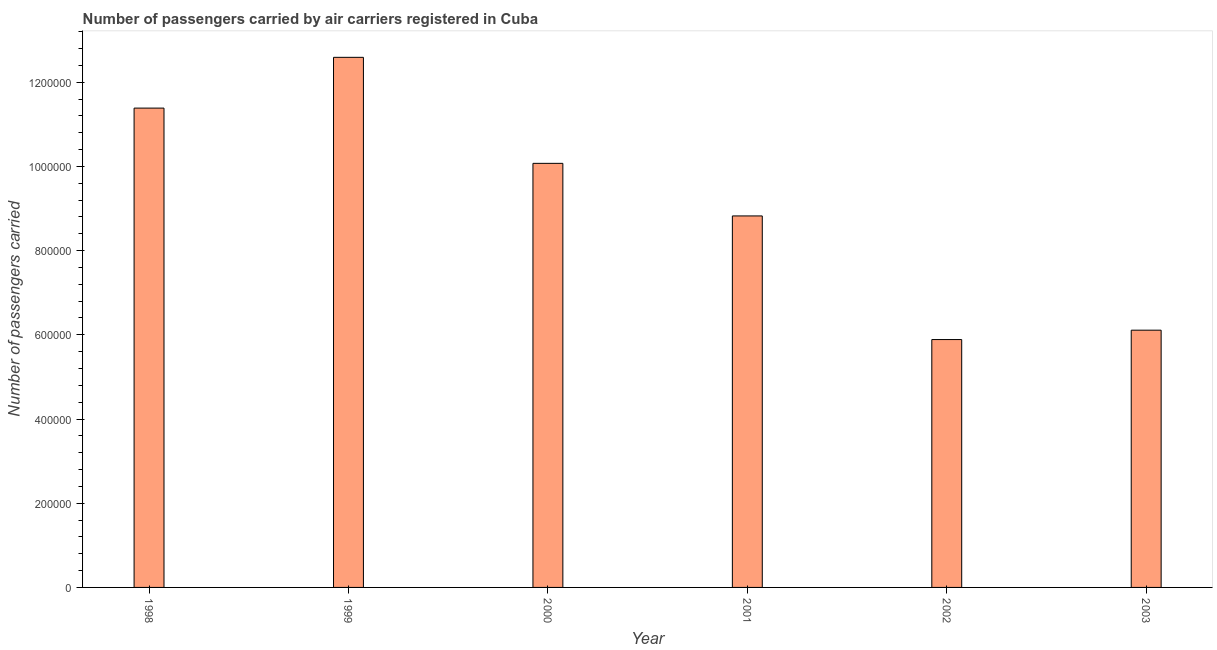Does the graph contain any zero values?
Offer a very short reply. No. Does the graph contain grids?
Offer a terse response. No. What is the title of the graph?
Your answer should be compact. Number of passengers carried by air carriers registered in Cuba. What is the label or title of the X-axis?
Provide a succinct answer. Year. What is the label or title of the Y-axis?
Offer a terse response. Number of passengers carried. What is the number of passengers carried in 2000?
Your response must be concise. 1.01e+06. Across all years, what is the maximum number of passengers carried?
Offer a terse response. 1.26e+06. Across all years, what is the minimum number of passengers carried?
Your answer should be compact. 5.89e+05. In which year was the number of passengers carried maximum?
Provide a short and direct response. 1999. What is the sum of the number of passengers carried?
Ensure brevity in your answer.  5.49e+06. What is the difference between the number of passengers carried in 2001 and 2003?
Ensure brevity in your answer.  2.71e+05. What is the average number of passengers carried per year?
Make the answer very short. 9.14e+05. What is the median number of passengers carried?
Give a very brief answer. 9.45e+05. In how many years, is the number of passengers carried greater than 1040000 ?
Provide a short and direct response. 2. Do a majority of the years between 2003 and 2000 (inclusive) have number of passengers carried greater than 120000 ?
Offer a very short reply. Yes. What is the ratio of the number of passengers carried in 1998 to that in 2003?
Your answer should be compact. 1.86. What is the difference between the highest and the second highest number of passengers carried?
Offer a very short reply. 1.21e+05. What is the difference between the highest and the lowest number of passengers carried?
Ensure brevity in your answer.  6.70e+05. How many bars are there?
Keep it short and to the point. 6. How many years are there in the graph?
Your answer should be compact. 6. What is the difference between two consecutive major ticks on the Y-axis?
Your answer should be very brief. 2.00e+05. Are the values on the major ticks of Y-axis written in scientific E-notation?
Give a very brief answer. No. What is the Number of passengers carried of 1998?
Offer a very short reply. 1.14e+06. What is the Number of passengers carried of 1999?
Offer a very short reply. 1.26e+06. What is the Number of passengers carried in 2000?
Your answer should be very brief. 1.01e+06. What is the Number of passengers carried of 2001?
Your answer should be compact. 8.82e+05. What is the Number of passengers carried in 2002?
Give a very brief answer. 5.89e+05. What is the Number of passengers carried in 2003?
Make the answer very short. 6.11e+05. What is the difference between the Number of passengers carried in 1998 and 1999?
Provide a succinct answer. -1.21e+05. What is the difference between the Number of passengers carried in 1998 and 2000?
Ensure brevity in your answer.  1.31e+05. What is the difference between the Number of passengers carried in 1998 and 2001?
Offer a very short reply. 2.56e+05. What is the difference between the Number of passengers carried in 1998 and 2002?
Offer a terse response. 5.50e+05. What is the difference between the Number of passengers carried in 1998 and 2003?
Ensure brevity in your answer.  5.27e+05. What is the difference between the Number of passengers carried in 1999 and 2000?
Offer a terse response. 2.52e+05. What is the difference between the Number of passengers carried in 1999 and 2001?
Provide a short and direct response. 3.77e+05. What is the difference between the Number of passengers carried in 1999 and 2002?
Offer a terse response. 6.70e+05. What is the difference between the Number of passengers carried in 1999 and 2003?
Offer a very short reply. 6.48e+05. What is the difference between the Number of passengers carried in 2000 and 2001?
Give a very brief answer. 1.25e+05. What is the difference between the Number of passengers carried in 2000 and 2002?
Give a very brief answer. 4.18e+05. What is the difference between the Number of passengers carried in 2000 and 2003?
Your answer should be very brief. 3.96e+05. What is the difference between the Number of passengers carried in 2001 and 2002?
Offer a terse response. 2.94e+05. What is the difference between the Number of passengers carried in 2001 and 2003?
Provide a short and direct response. 2.71e+05. What is the difference between the Number of passengers carried in 2002 and 2003?
Ensure brevity in your answer.  -2.23e+04. What is the ratio of the Number of passengers carried in 1998 to that in 1999?
Provide a short and direct response. 0.9. What is the ratio of the Number of passengers carried in 1998 to that in 2000?
Your answer should be compact. 1.13. What is the ratio of the Number of passengers carried in 1998 to that in 2001?
Provide a succinct answer. 1.29. What is the ratio of the Number of passengers carried in 1998 to that in 2002?
Offer a very short reply. 1.93. What is the ratio of the Number of passengers carried in 1998 to that in 2003?
Give a very brief answer. 1.86. What is the ratio of the Number of passengers carried in 1999 to that in 2000?
Ensure brevity in your answer.  1.25. What is the ratio of the Number of passengers carried in 1999 to that in 2001?
Provide a succinct answer. 1.43. What is the ratio of the Number of passengers carried in 1999 to that in 2002?
Provide a succinct answer. 2.14. What is the ratio of the Number of passengers carried in 1999 to that in 2003?
Offer a very short reply. 2.06. What is the ratio of the Number of passengers carried in 2000 to that in 2001?
Your response must be concise. 1.14. What is the ratio of the Number of passengers carried in 2000 to that in 2002?
Ensure brevity in your answer.  1.71. What is the ratio of the Number of passengers carried in 2000 to that in 2003?
Offer a terse response. 1.65. What is the ratio of the Number of passengers carried in 2001 to that in 2002?
Your answer should be compact. 1.5. What is the ratio of the Number of passengers carried in 2001 to that in 2003?
Keep it short and to the point. 1.44. 